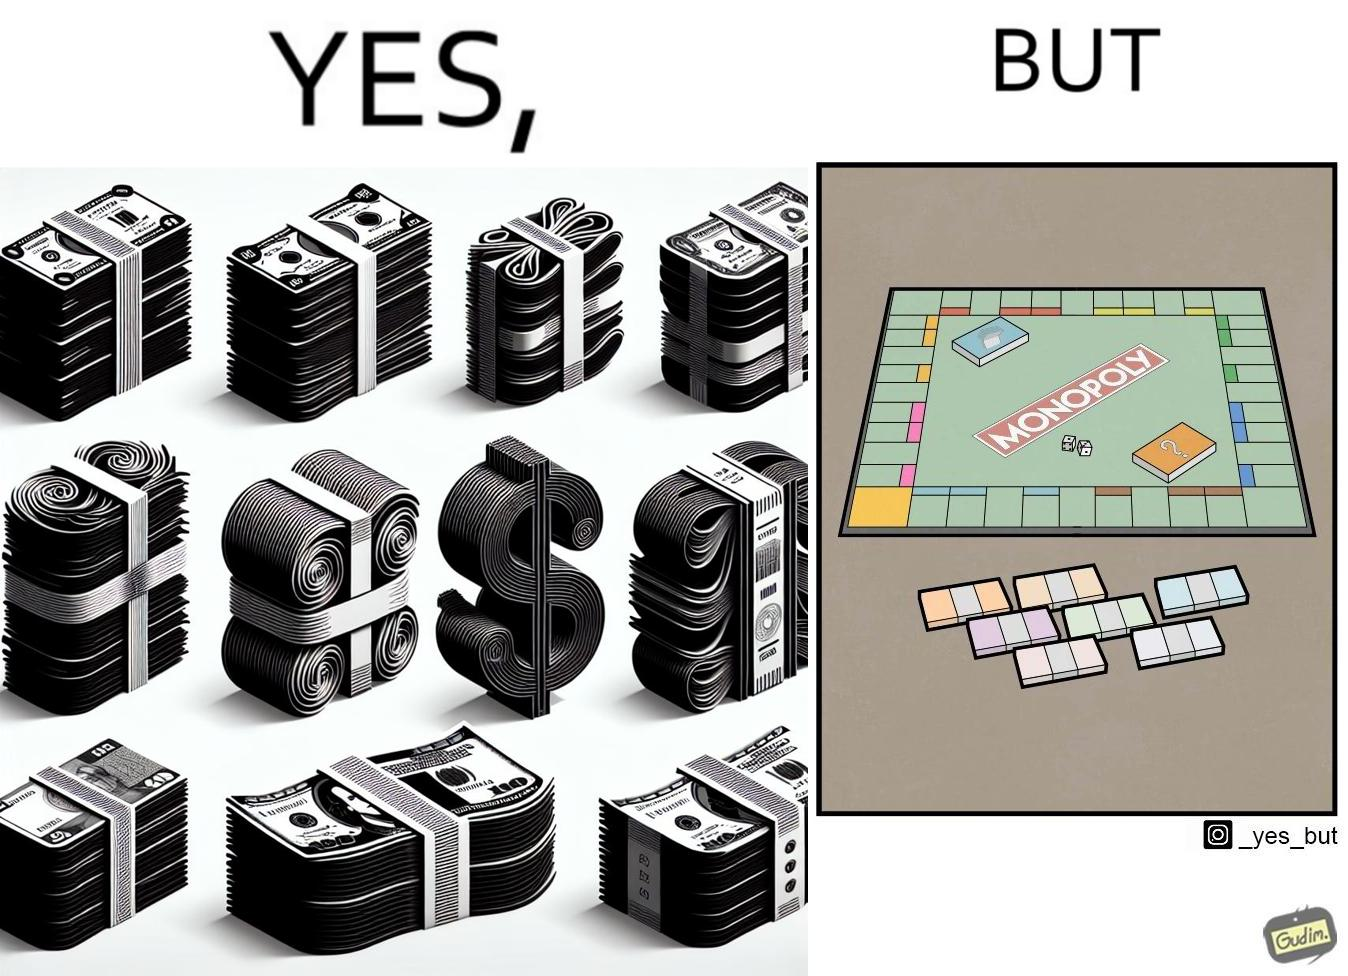Is this a satirical image? Yes, this image is satirical. 